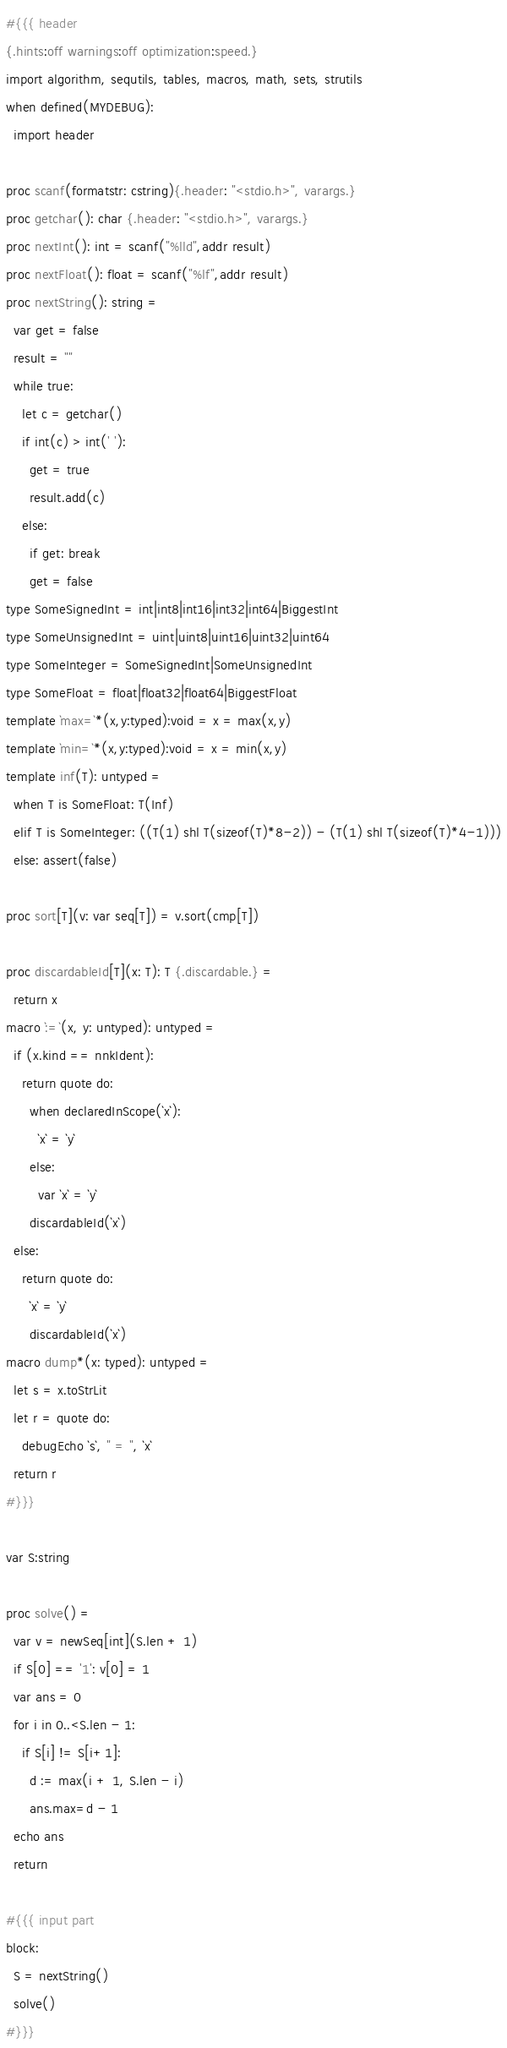<code> <loc_0><loc_0><loc_500><loc_500><_Nim_>#{{{ header
{.hints:off warnings:off optimization:speed.}
import algorithm, sequtils, tables, macros, math, sets, strutils
when defined(MYDEBUG):
  import header

proc scanf(formatstr: cstring){.header: "<stdio.h>", varargs.}
proc getchar(): char {.header: "<stdio.h>", varargs.}
proc nextInt(): int = scanf("%lld",addr result)
proc nextFloat(): float = scanf("%lf",addr result)
proc nextString(): string =
  var get = false
  result = ""
  while true:
    let c = getchar()
    if int(c) > int(' '):
      get = true
      result.add(c)
    else:
      if get: break
      get = false
type SomeSignedInt = int|int8|int16|int32|int64|BiggestInt
type SomeUnsignedInt = uint|uint8|uint16|uint32|uint64
type SomeInteger = SomeSignedInt|SomeUnsignedInt
type SomeFloat = float|float32|float64|BiggestFloat
template `max=`*(x,y:typed):void = x = max(x,y)
template `min=`*(x,y:typed):void = x = min(x,y)
template inf(T): untyped = 
  when T is SomeFloat: T(Inf)
  elif T is SomeInteger: ((T(1) shl T(sizeof(T)*8-2)) - (T(1) shl T(sizeof(T)*4-1)))
  else: assert(false)

proc sort[T](v: var seq[T]) = v.sort(cmp[T])

proc discardableId[T](x: T): T {.discardable.} =
  return x
macro `:=`(x, y: untyped): untyped =
  if (x.kind == nnkIdent):
    return quote do:
      when declaredInScope(`x`):
        `x` = `y`
      else:
        var `x` = `y`
      discardableId(`x`)
  else:
    return quote do:
      `x` = `y`
      discardableId(`x`)
macro dump*(x: typed): untyped =
  let s = x.toStrLit
  let r = quote do:
    debugEcho `s`, " = ", `x`
  return r
#}}}

var S:string

proc solve() =
  var v = newSeq[int](S.len + 1)
  if S[0] == '1': v[0] = 1
  var ans = 0
  for i in 0..<S.len - 1:
    if S[i] != S[i+1]:
      d := max(i + 1, S.len - i)
      ans.max=d - 1
  echo ans
  return

#{{{ input part
block:
  S = nextString()
  solve()
#}}}
</code> 